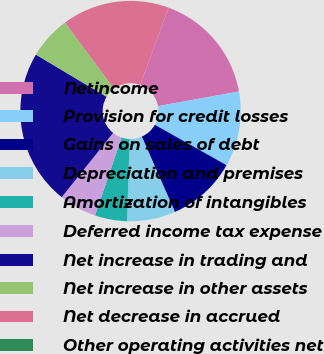Convert chart. <chart><loc_0><loc_0><loc_500><loc_500><pie_chart><fcel>Netincome<fcel>Provision for credit losses<fcel>Gains on sales of debt<fcel>Depreciation and premises<fcel>Amortization of intangibles<fcel>Deferred income tax expense<fcel>Net increase in trading and<fcel>Net increase in other assets<fcel>Net decrease in accrued<fcel>Other operating activities net<nl><fcel>16.53%<fcel>11.02%<fcel>10.24%<fcel>7.09%<fcel>4.72%<fcel>5.51%<fcel>22.83%<fcel>6.3%<fcel>15.75%<fcel>0.0%<nl></chart> 